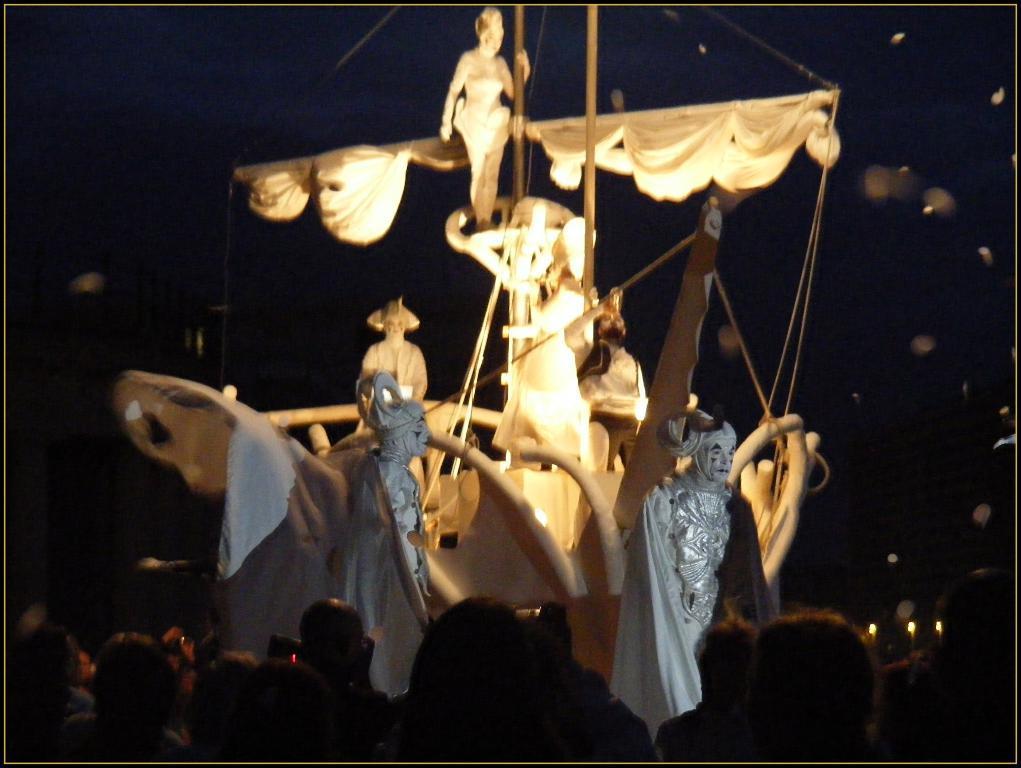Can you describe this image briefly? In this image there is a model of the sip with sculptures, rods, poles and lights. At the bottom of the image there are few people. There is a black color background. 